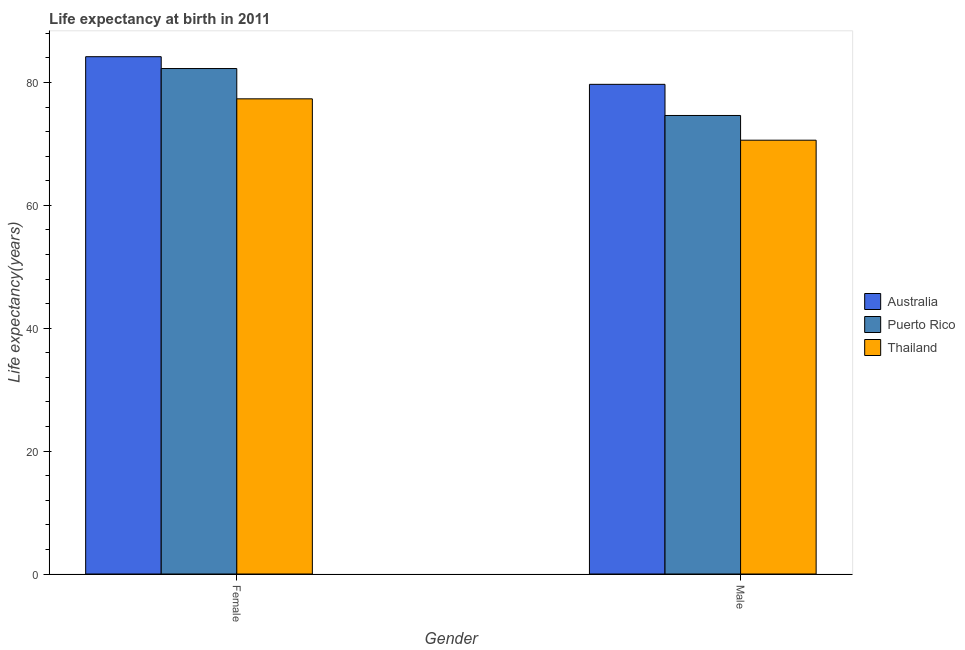How many groups of bars are there?
Your answer should be very brief. 2. Are the number of bars per tick equal to the number of legend labels?
Provide a succinct answer. Yes. How many bars are there on the 2nd tick from the left?
Offer a terse response. 3. What is the label of the 1st group of bars from the left?
Keep it short and to the point. Female. What is the life expectancy(male) in Thailand?
Keep it short and to the point. 70.61. Across all countries, what is the maximum life expectancy(female)?
Make the answer very short. 84.2. Across all countries, what is the minimum life expectancy(female)?
Your answer should be very brief. 77.34. In which country was the life expectancy(male) maximum?
Provide a succinct answer. Australia. In which country was the life expectancy(male) minimum?
Provide a short and direct response. Thailand. What is the total life expectancy(female) in the graph?
Your response must be concise. 243.81. What is the difference between the life expectancy(male) in Australia and that in Thailand?
Your answer should be compact. 9.09. What is the difference between the life expectancy(female) in Thailand and the life expectancy(male) in Puerto Rico?
Keep it short and to the point. 2.71. What is the average life expectancy(female) per country?
Provide a succinct answer. 81.27. What is the difference between the life expectancy(male) and life expectancy(female) in Puerto Rico?
Offer a very short reply. -7.64. What is the ratio of the life expectancy(male) in Thailand to that in Puerto Rico?
Provide a short and direct response. 0.95. Is the life expectancy(male) in Puerto Rico less than that in Thailand?
Ensure brevity in your answer.  No. What does the 3rd bar from the left in Female represents?
Provide a succinct answer. Thailand. Are the values on the major ticks of Y-axis written in scientific E-notation?
Provide a short and direct response. No. Does the graph contain any zero values?
Your answer should be very brief. No. Does the graph contain grids?
Offer a terse response. No. Where does the legend appear in the graph?
Your response must be concise. Center right. What is the title of the graph?
Offer a very short reply. Life expectancy at birth in 2011. What is the label or title of the X-axis?
Provide a short and direct response. Gender. What is the label or title of the Y-axis?
Your response must be concise. Life expectancy(years). What is the Life expectancy(years) of Australia in Female?
Provide a short and direct response. 84.2. What is the Life expectancy(years) of Puerto Rico in Female?
Provide a short and direct response. 82.27. What is the Life expectancy(years) in Thailand in Female?
Your response must be concise. 77.34. What is the Life expectancy(years) of Australia in Male?
Offer a terse response. 79.7. What is the Life expectancy(years) in Puerto Rico in Male?
Your answer should be compact. 74.63. What is the Life expectancy(years) in Thailand in Male?
Make the answer very short. 70.61. Across all Gender, what is the maximum Life expectancy(years) of Australia?
Your response must be concise. 84.2. Across all Gender, what is the maximum Life expectancy(years) of Puerto Rico?
Provide a succinct answer. 82.27. Across all Gender, what is the maximum Life expectancy(years) of Thailand?
Provide a short and direct response. 77.34. Across all Gender, what is the minimum Life expectancy(years) of Australia?
Give a very brief answer. 79.7. Across all Gender, what is the minimum Life expectancy(years) of Puerto Rico?
Offer a terse response. 74.63. Across all Gender, what is the minimum Life expectancy(years) of Thailand?
Make the answer very short. 70.61. What is the total Life expectancy(years) in Australia in the graph?
Your answer should be very brief. 163.9. What is the total Life expectancy(years) of Puerto Rico in the graph?
Provide a succinct answer. 156.9. What is the total Life expectancy(years) in Thailand in the graph?
Offer a terse response. 147.95. What is the difference between the Life expectancy(years) in Puerto Rico in Female and that in Male?
Keep it short and to the point. 7.64. What is the difference between the Life expectancy(years) of Thailand in Female and that in Male?
Your response must be concise. 6.73. What is the difference between the Life expectancy(years) of Australia in Female and the Life expectancy(years) of Puerto Rico in Male?
Ensure brevity in your answer.  9.57. What is the difference between the Life expectancy(years) in Australia in Female and the Life expectancy(years) in Thailand in Male?
Your answer should be very brief. 13.59. What is the difference between the Life expectancy(years) in Puerto Rico in Female and the Life expectancy(years) in Thailand in Male?
Your response must be concise. 11.66. What is the average Life expectancy(years) in Australia per Gender?
Your response must be concise. 81.95. What is the average Life expectancy(years) in Puerto Rico per Gender?
Offer a very short reply. 78.45. What is the average Life expectancy(years) of Thailand per Gender?
Offer a very short reply. 73.97. What is the difference between the Life expectancy(years) in Australia and Life expectancy(years) in Puerto Rico in Female?
Offer a very short reply. 1.93. What is the difference between the Life expectancy(years) of Australia and Life expectancy(years) of Thailand in Female?
Your answer should be compact. 6.86. What is the difference between the Life expectancy(years) of Puerto Rico and Life expectancy(years) of Thailand in Female?
Your response must be concise. 4.93. What is the difference between the Life expectancy(years) of Australia and Life expectancy(years) of Puerto Rico in Male?
Offer a terse response. 5.07. What is the difference between the Life expectancy(years) in Australia and Life expectancy(years) in Thailand in Male?
Make the answer very short. 9.09. What is the difference between the Life expectancy(years) of Puerto Rico and Life expectancy(years) of Thailand in Male?
Provide a succinct answer. 4.03. What is the ratio of the Life expectancy(years) in Australia in Female to that in Male?
Your answer should be compact. 1.06. What is the ratio of the Life expectancy(years) in Puerto Rico in Female to that in Male?
Provide a succinct answer. 1.1. What is the ratio of the Life expectancy(years) of Thailand in Female to that in Male?
Make the answer very short. 1.1. What is the difference between the highest and the second highest Life expectancy(years) of Australia?
Provide a short and direct response. 4.5. What is the difference between the highest and the second highest Life expectancy(years) in Puerto Rico?
Offer a terse response. 7.64. What is the difference between the highest and the second highest Life expectancy(years) in Thailand?
Keep it short and to the point. 6.73. What is the difference between the highest and the lowest Life expectancy(years) of Puerto Rico?
Make the answer very short. 7.64. What is the difference between the highest and the lowest Life expectancy(years) of Thailand?
Keep it short and to the point. 6.73. 